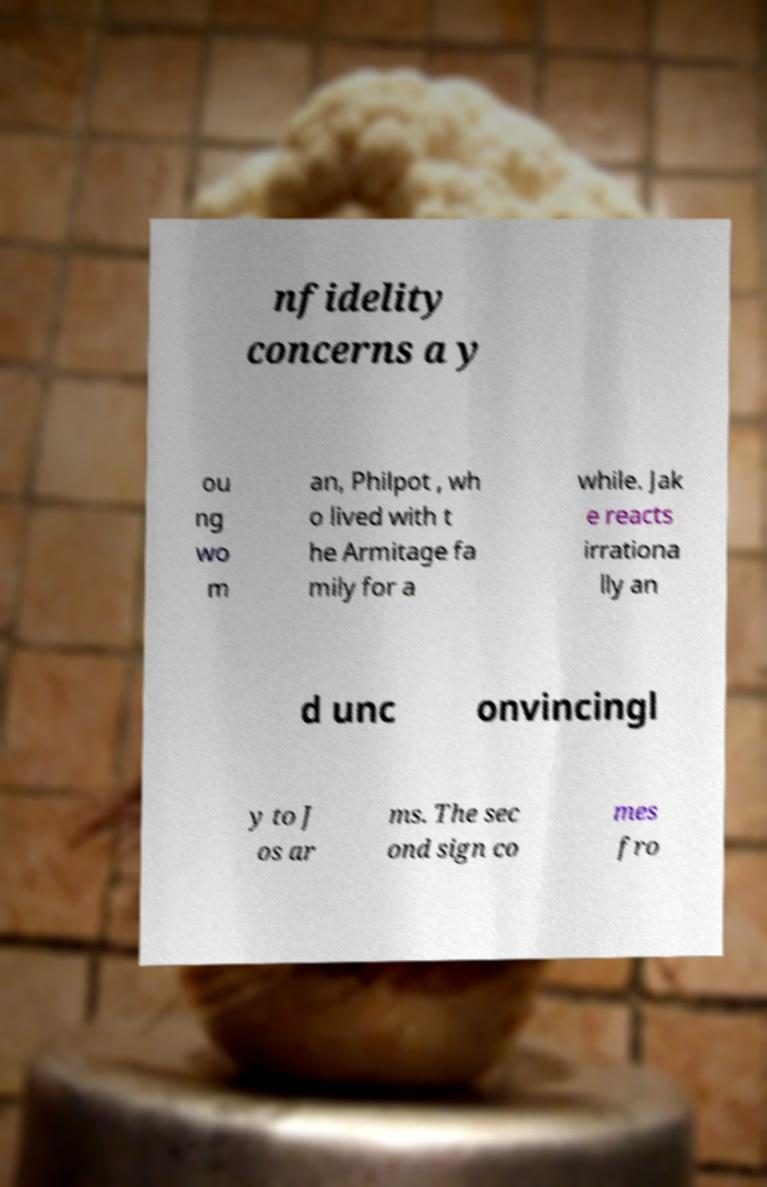Can you read and provide the text displayed in the image?This photo seems to have some interesting text. Can you extract and type it out for me? nfidelity concerns a y ou ng wo m an, Philpot , wh o lived with t he Armitage fa mily for a while. Jak e reacts irrationa lly an d unc onvincingl y to J os ar ms. The sec ond sign co mes fro 